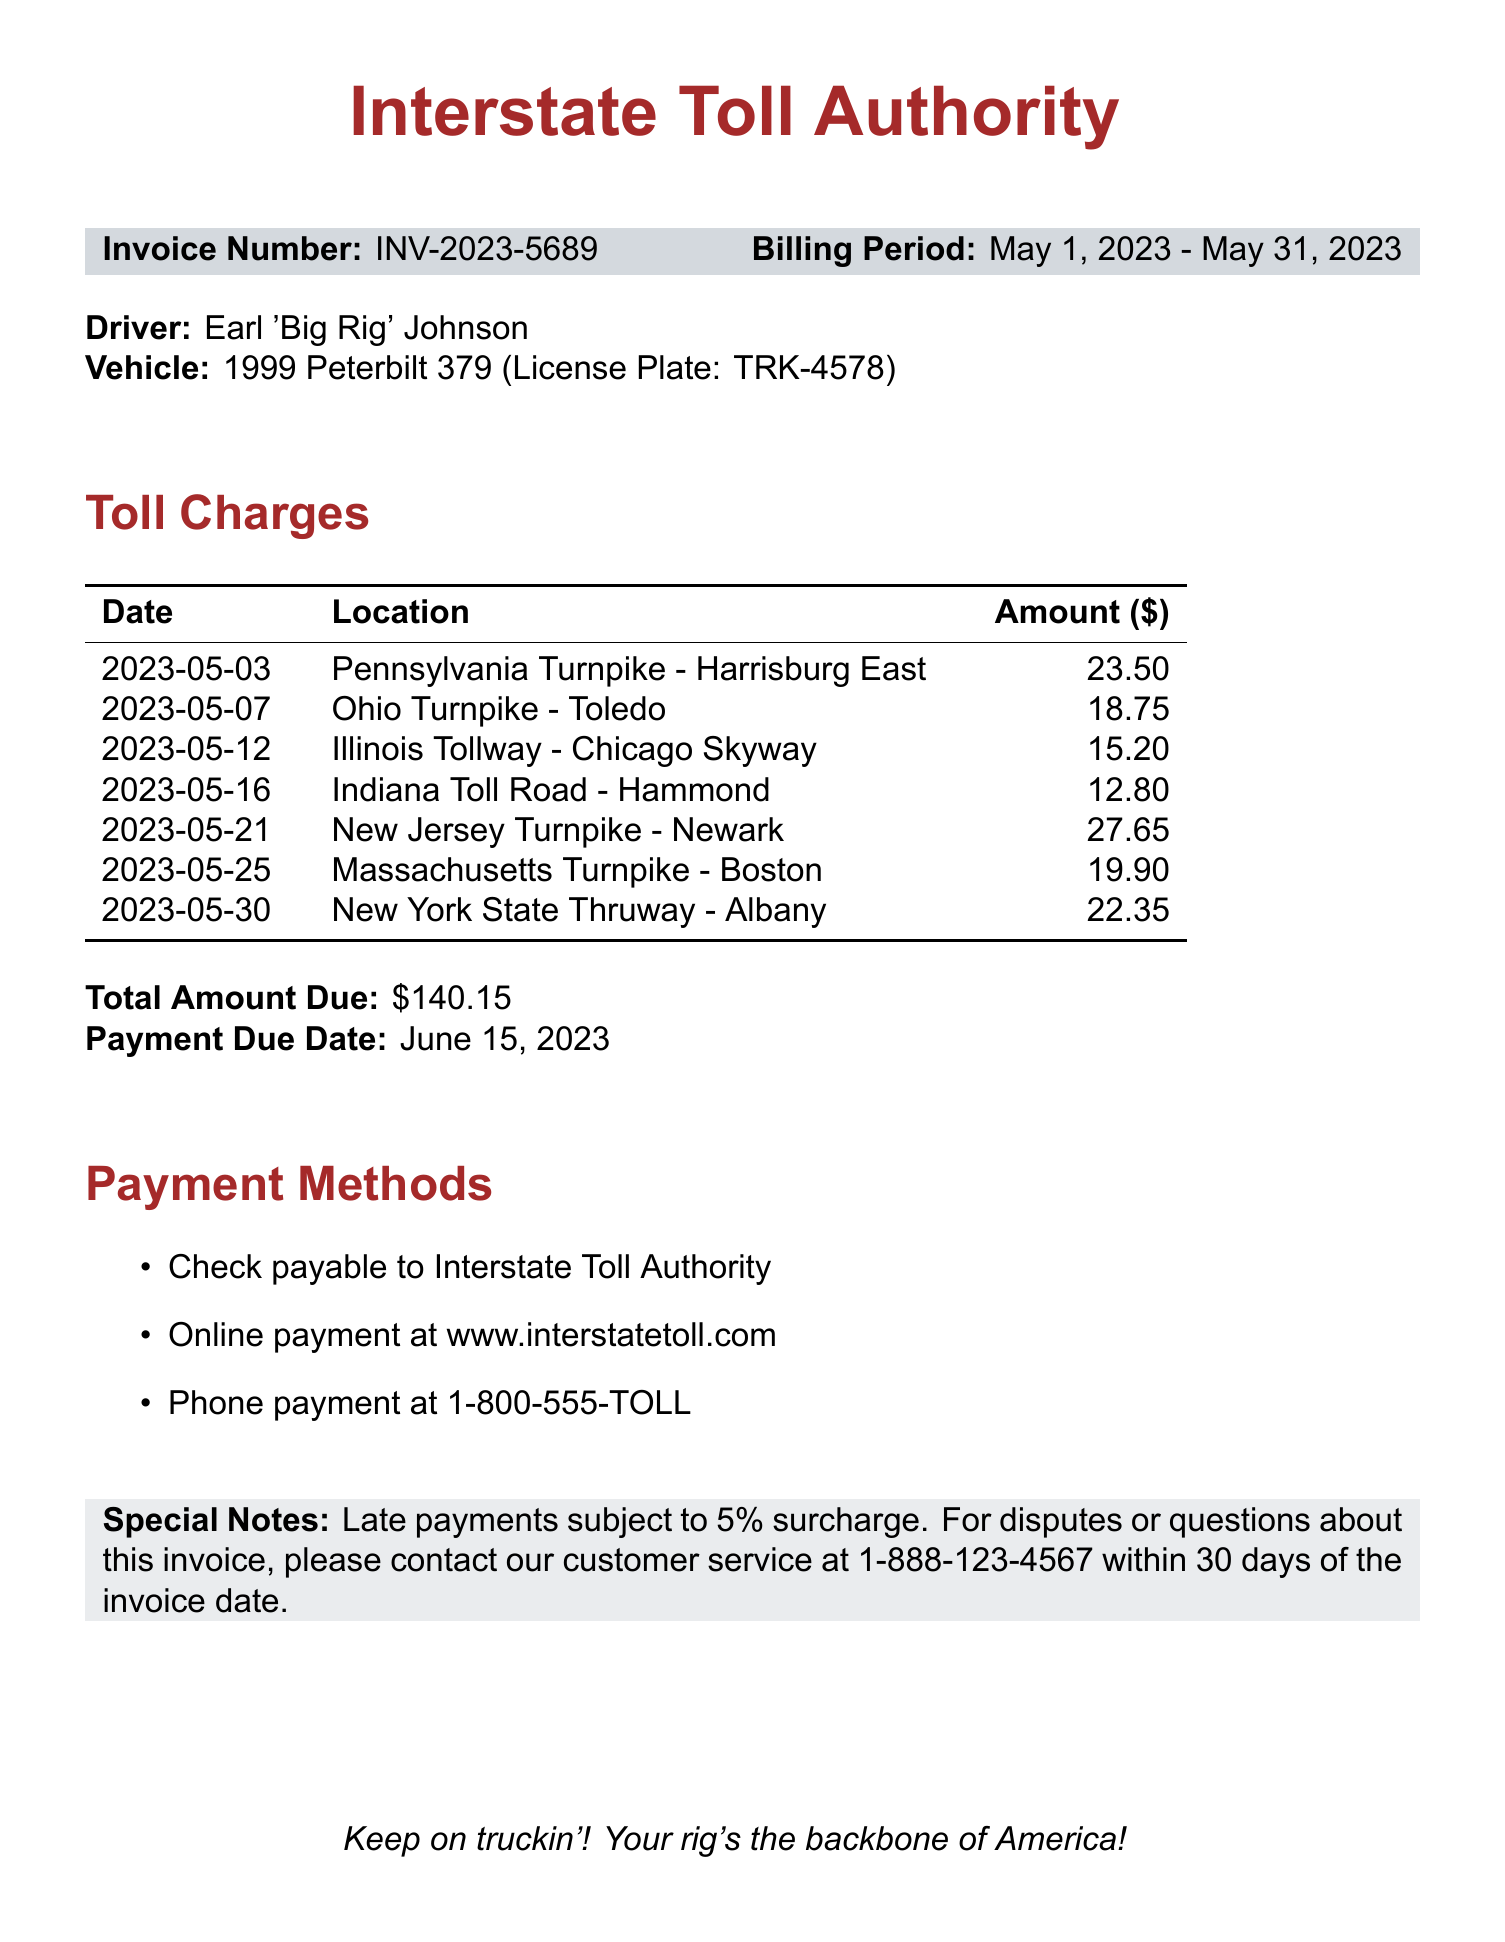What is the invoice number? The invoice number is specified in the document to identify the invoice uniquely.
Answer: INV-2023-5689 Who is the driver named in the document? The driver's name is clearly mentioned in the document under the driver details.
Answer: Earl 'Big Rig' Johnson What is the total amount due? The total amount due is the sum of all toll charges listed in the document.
Answer: $140.15 When is the payment due date? The payment due date is provided to inform when the payment should be made.
Answer: June 15, 2023 What is the amount for the toll on May 21? The amount for the toll on a specific date is listed to detail individual charges.
Answer: $27.65 How many toll charges are listed in the document? The number of toll charges indicates how many fees are detailed in the invoice.
Answer: 7 What payment methods are available? The payment methods are listed to inform the driver how they can pay the toll invoice.
Answer: Check, Online, Phone What is the special note regarding late payments? The special note indicates the consequence of not paying on time as outlined in the invoice.
Answer: 5% surcharge Which toll location had the highest charge? The location with the highest charge indicates where the driver incurred the most expense.
Answer: New Jersey Turnpike - Newark 